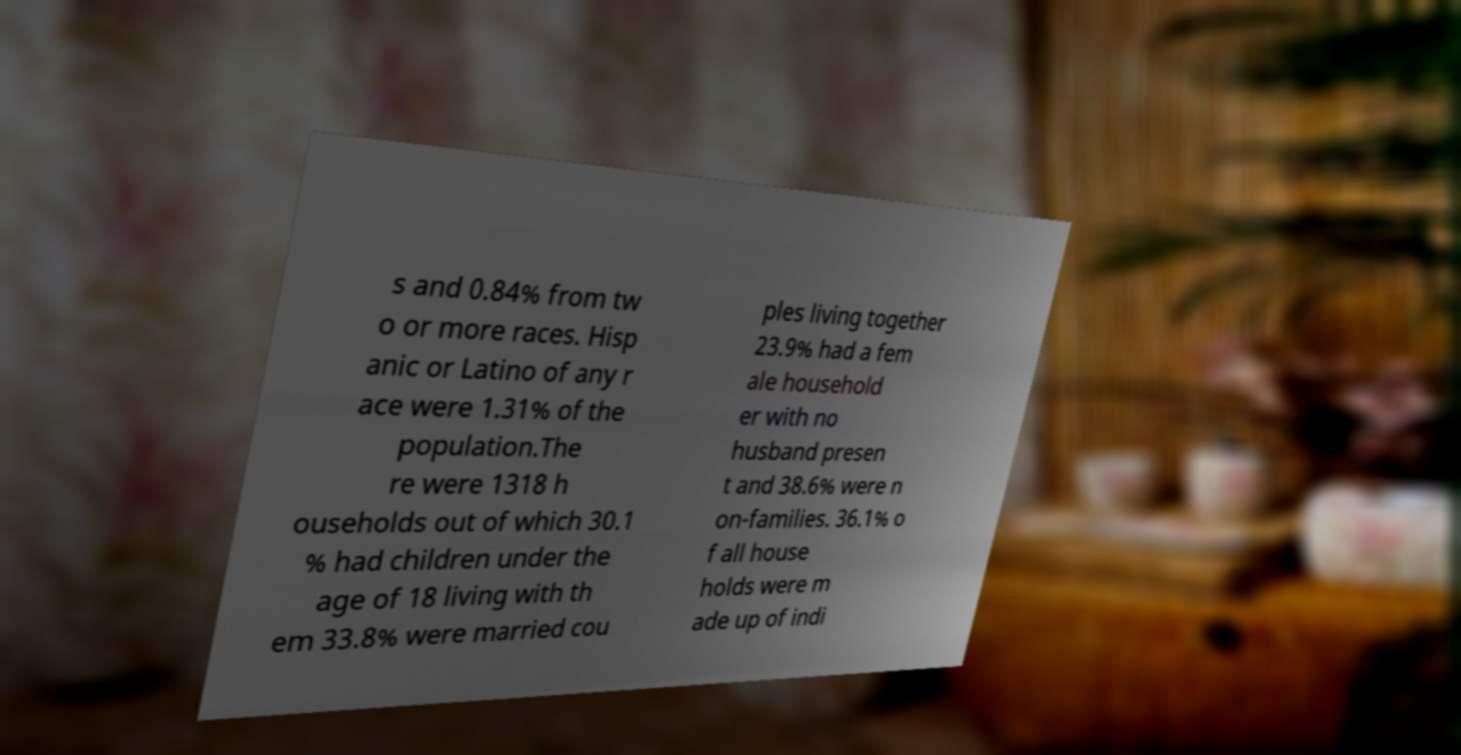Please identify and transcribe the text found in this image. s and 0.84% from tw o or more races. Hisp anic or Latino of any r ace were 1.31% of the population.The re were 1318 h ouseholds out of which 30.1 % had children under the age of 18 living with th em 33.8% were married cou ples living together 23.9% had a fem ale household er with no husband presen t and 38.6% were n on-families. 36.1% o f all house holds were m ade up of indi 